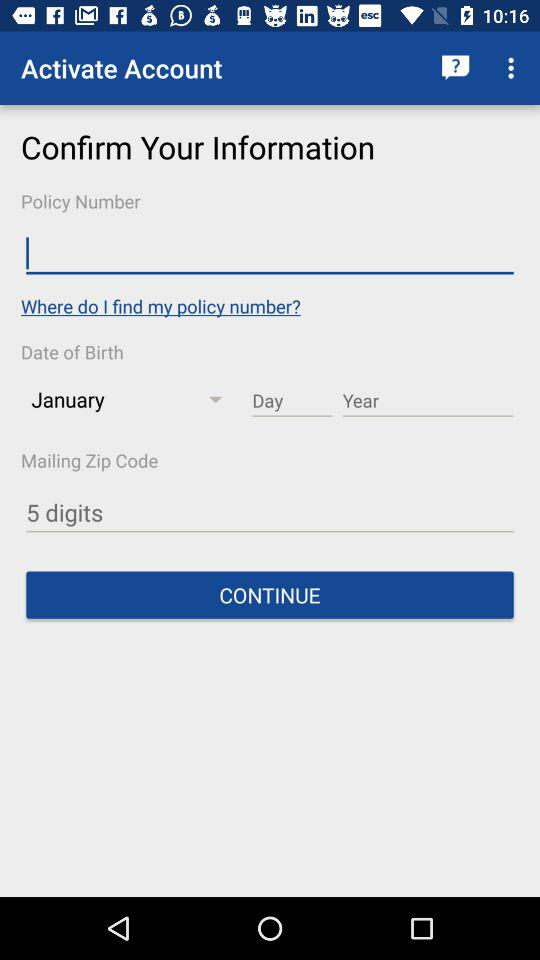Which month is selected? The selected month is January. 